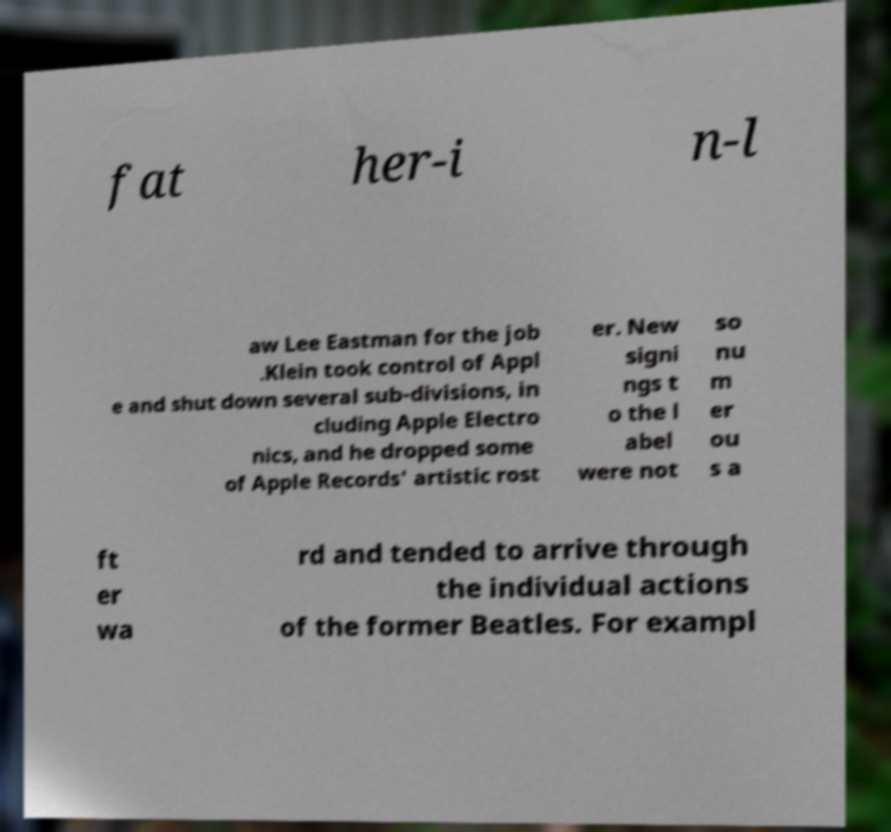Could you extract and type out the text from this image? fat her-i n-l aw Lee Eastman for the job .Klein took control of Appl e and shut down several sub-divisions, in cluding Apple Electro nics, and he dropped some of Apple Records' artistic rost er. New signi ngs t o the l abel were not so nu m er ou s a ft er wa rd and tended to arrive through the individual actions of the former Beatles. For exampl 